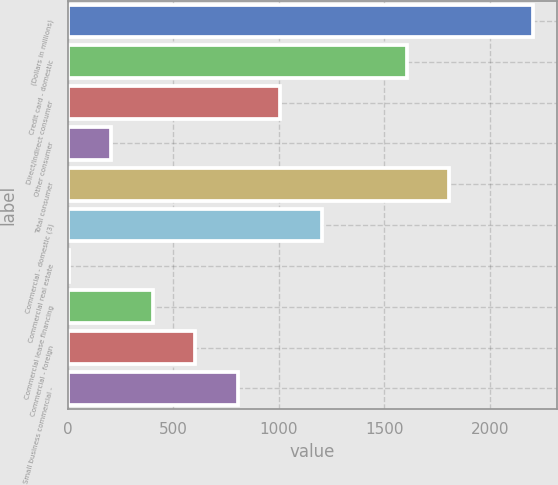Convert chart to OTSL. <chart><loc_0><loc_0><loc_500><loc_500><bar_chart><fcel>(Dollars in millions)<fcel>Credit card - domestic<fcel>Direct/Indirect consumer<fcel>Other consumer<fcel>Total consumer<fcel>Commercial - domestic (3)<fcel>Commercial real estate<fcel>Commercial lease financing<fcel>Commercial - foreign<fcel>Small business commercial -<nl><fcel>2205.1<fcel>1604.8<fcel>1004.5<fcel>204.1<fcel>1804.9<fcel>1204.6<fcel>4<fcel>404.2<fcel>604.3<fcel>804.4<nl></chart> 